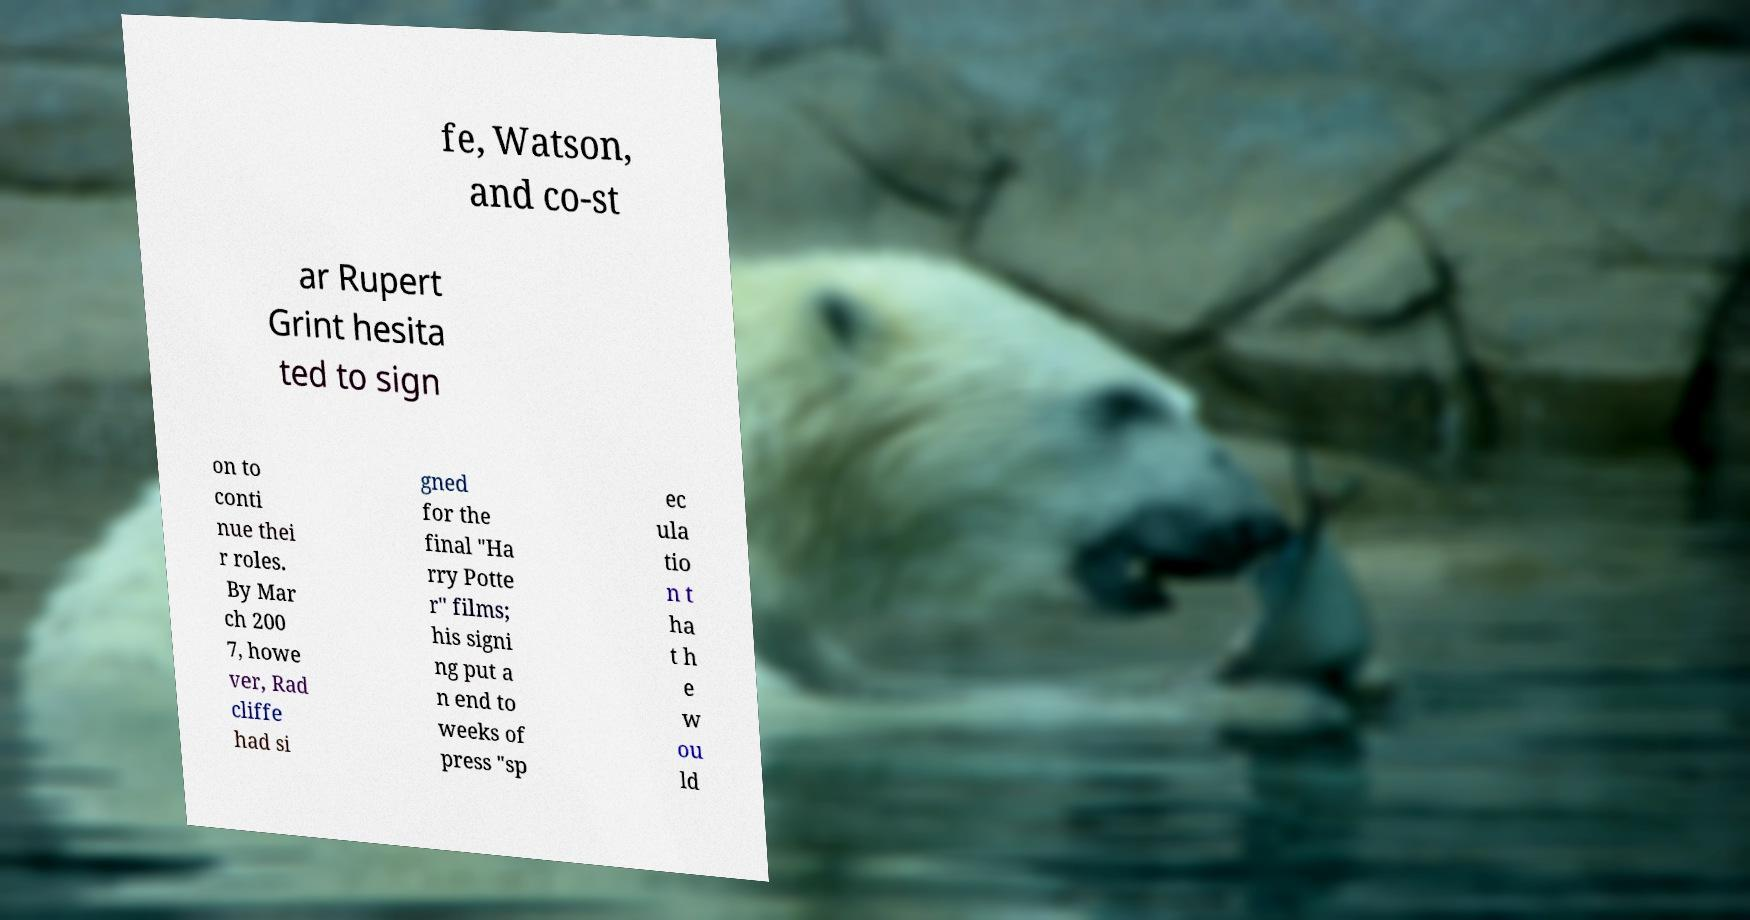Can you accurately transcribe the text from the provided image for me? fe, Watson, and co-st ar Rupert Grint hesita ted to sign on to conti nue thei r roles. By Mar ch 200 7, howe ver, Rad cliffe had si gned for the final "Ha rry Potte r" films; his signi ng put a n end to weeks of press "sp ec ula tio n t ha t h e w ou ld 